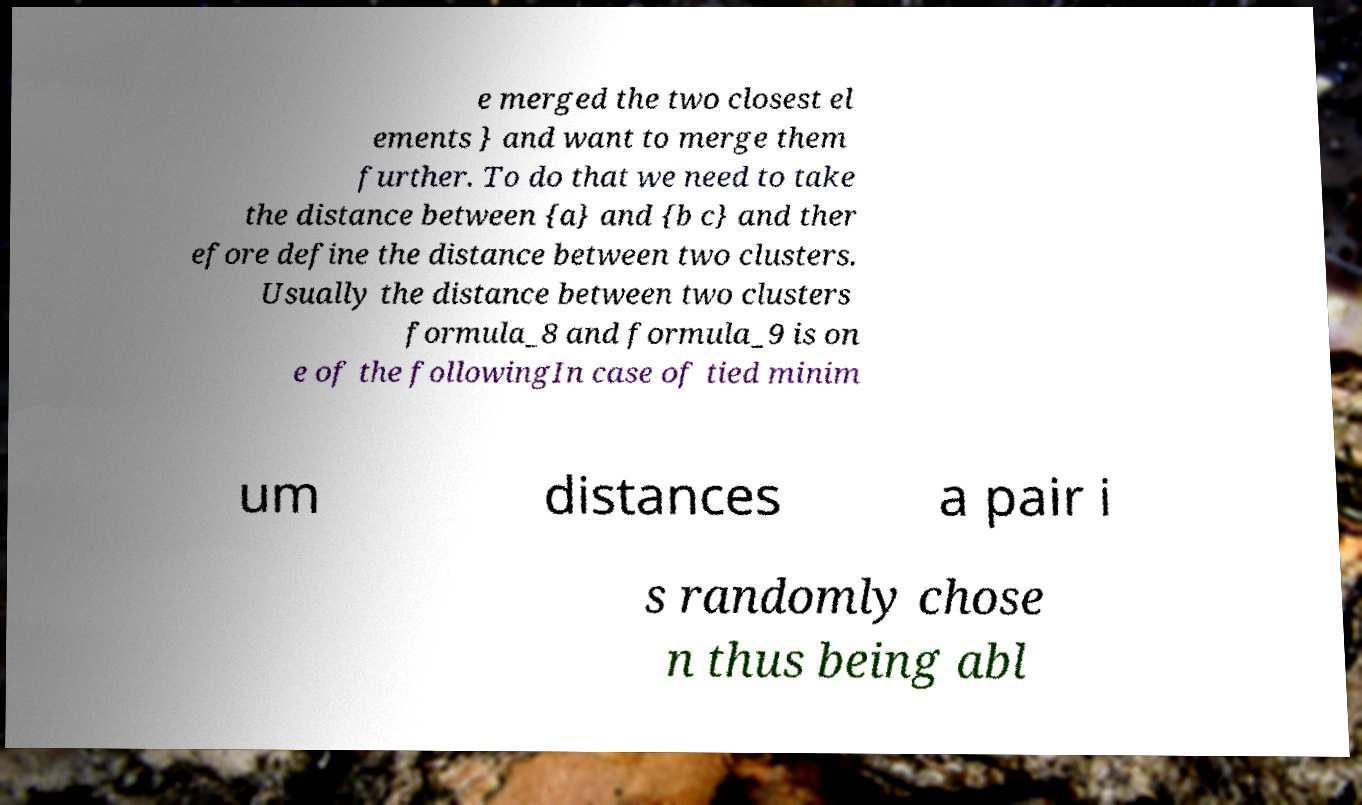Can you read and provide the text displayed in the image?This photo seems to have some interesting text. Can you extract and type it out for me? e merged the two closest el ements } and want to merge them further. To do that we need to take the distance between {a} and {b c} and ther efore define the distance between two clusters. Usually the distance between two clusters formula_8 and formula_9 is on e of the followingIn case of tied minim um distances a pair i s randomly chose n thus being abl 